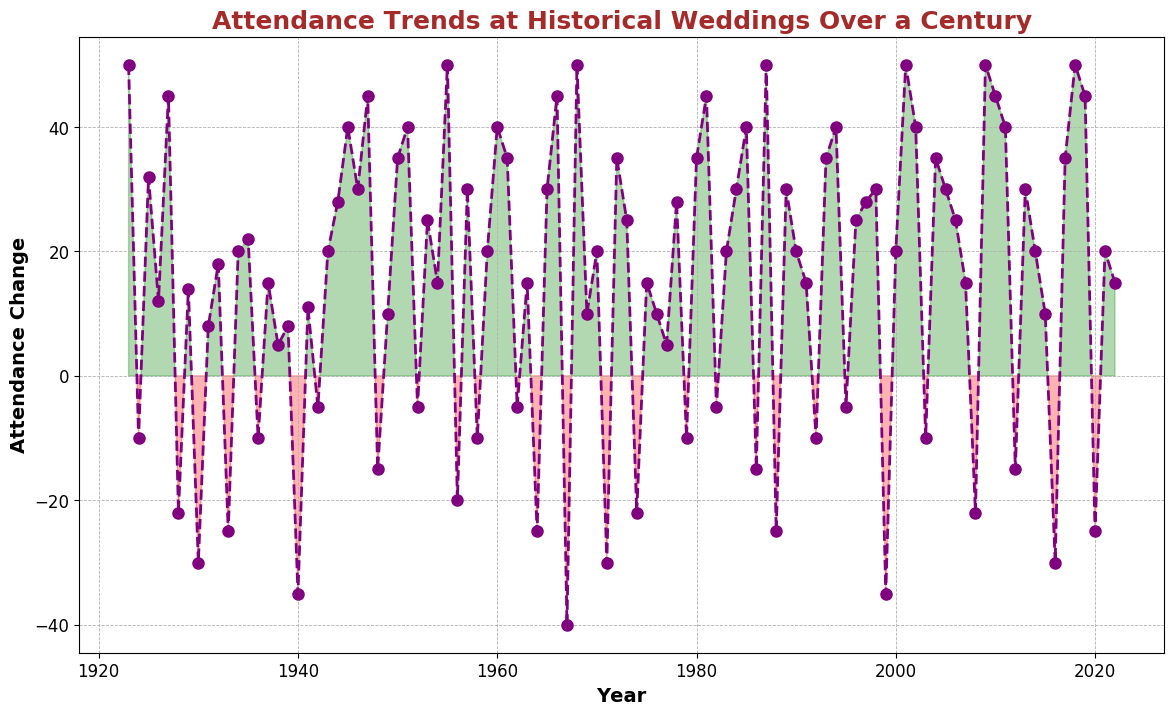What's the highest positive attendance change in the century? The highest positive attendance change is found by identifying the peak value on the y-axis within the green-shaded areas. The highest peak is at +50 and occurs multiple times, including the years 1923, 1968, 1987, 2001, 2009, and 2018.
Answer: 50 Which year had the lowest negative attendance change and what was its value? The lowest negative attendance change is found by identifying the deepest drop on the y-axis within the red-shaded areas. The lowest point is at -40 and occurred in 1967.
Answer: 1967, -40 What's the range of the attendance change over the century? The range is calculated by finding the difference between the highest positive change (50) and the lowest negative change (-40). This is 50 - (-40) = 50 + 40 = 90.
Answer: 90 In which decades did the attendance change drop below -20? Attendance changes below -20 are visually identified in the red-shaded areas. The decades where this occurs are the 1920s (1928), 1940s (1940), 1960s (1967), 1970s (1971 and 1974), 1980s (1988), and 1990s (1999).
Answer: 1920s, 1940s, 1960s, 1970s, 1980s, 1990s What is the average attendance change in the 1950s? To find the average, sum the attendance changes in the 1950s and then divide by the number of years (10). The values are: 50, -20, 30, -10, 20, 40, 35, -5, 15, and 50. Sum = (50 - 20 + 30 - 10 + 20 + 40 + 35 - 5 + 15 + 50) = 205. Then, 205 / 10 = 20.5
Answer: 20.5 How many years show a positive attendance change? Years with positive attendance changes are found in the green-shaded areas. Count these years: 1923, 1925, 1926, 1927, 1929, 1931, 1932, 1934, 1935, 1937, 1938, 1939, 1941, 1943, 1944, 1945, 1946, 1947, 1949, 1950, 1951, 1953, 1954, 1955, 1957, 1959, 1960, 1961, 1963, 1965, 1966, 1968, 1969, 1970, 1972, 1973, 1975, 1976, 1977, 1978, 1980, 1981, 1983, 1984, 1985, 1987, 1989, 1990, 1991, 1993, 1994, 1996, 1997, 1998, 2000, 2001, 2002, 2004, 2005, 2006, 2007, 2009, 2010, 2011, 2013, 2014, 2015, 2017, 2018, 2019, 2021, 2022. Total is 73 years.
Answer: 73 